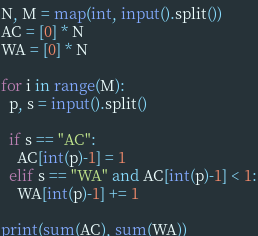Convert code to text. <code><loc_0><loc_0><loc_500><loc_500><_Python_>N, M = map(int, input().split())
AC = [0] * N
WA = [0] * N

for i in range(M):
  p, s = input().split()
  
  if s == "AC":
    AC[int(p)-1] = 1
  elif s == "WA" and AC[int(p)-1] < 1:
    WA[int(p)-1] += 1
  
print(sum(AC), sum(WA))
</code> 